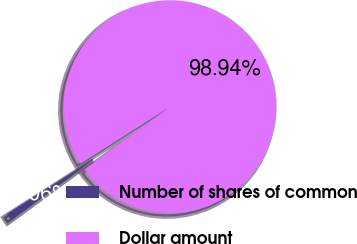<chart> <loc_0><loc_0><loc_500><loc_500><pie_chart><fcel>Number of shares of common<fcel>Dollar amount<nl><fcel>1.06%<fcel>98.94%<nl></chart> 